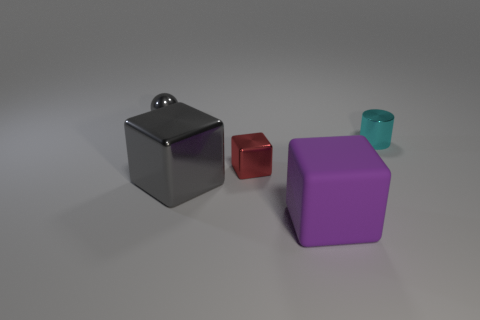Subtract all large purple blocks. How many blocks are left? 2 Subtract all red cubes. How many cubes are left? 2 Add 1 cyan cylinders. How many objects exist? 6 Subtract 2 blocks. How many blocks are left? 1 Subtract all brown spheres. Subtract all gray cylinders. How many spheres are left? 1 Subtract all tiny brown objects. Subtract all large rubber things. How many objects are left? 4 Add 4 red objects. How many red objects are left? 5 Add 1 large green shiny things. How many large green shiny things exist? 1 Subtract 0 gray cylinders. How many objects are left? 5 Subtract all cylinders. How many objects are left? 4 